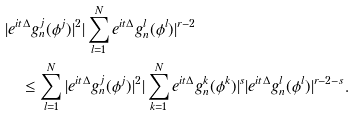Convert formula to latex. <formula><loc_0><loc_0><loc_500><loc_500>& | e ^ { i t \Delta } g _ { n } ^ { j } ( \phi ^ { j } ) | ^ { 2 } | \sum _ { l = 1 } ^ { N } e ^ { i t \Delta } g _ { n } ^ { l } ( \phi ^ { l } ) | ^ { r - 2 } \\ & \quad \leq \sum _ { l = 1 } ^ { N } | e ^ { i t \Delta } g _ { n } ^ { j } ( \phi ^ { j } ) | ^ { 2 } | \sum _ { k = 1 } ^ { N } e ^ { i t \Delta } g _ { n } ^ { k } ( \phi ^ { k } ) | ^ { s } | e ^ { i t \Delta } g _ { n } ^ { l } ( \phi ^ { l } ) | ^ { r - 2 - s } .</formula> 